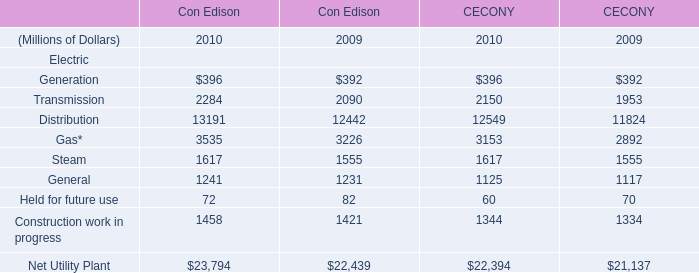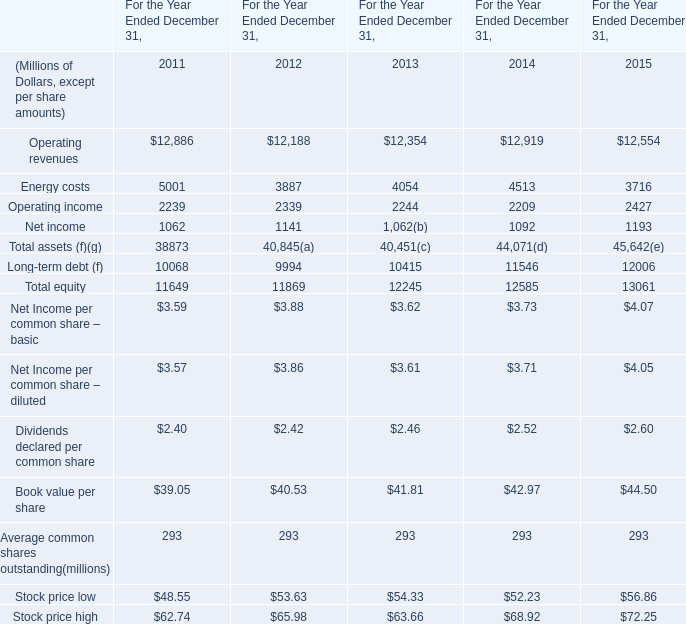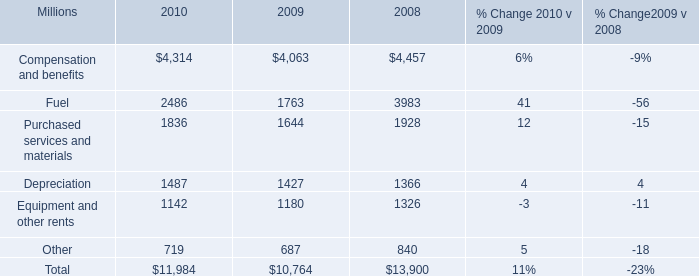what's the total amount of Equipment and other rents of 2010, and Transmission of Con Edison 2010 ? 
Computations: (1142.0 + 2284.0)
Answer: 3426.0. 